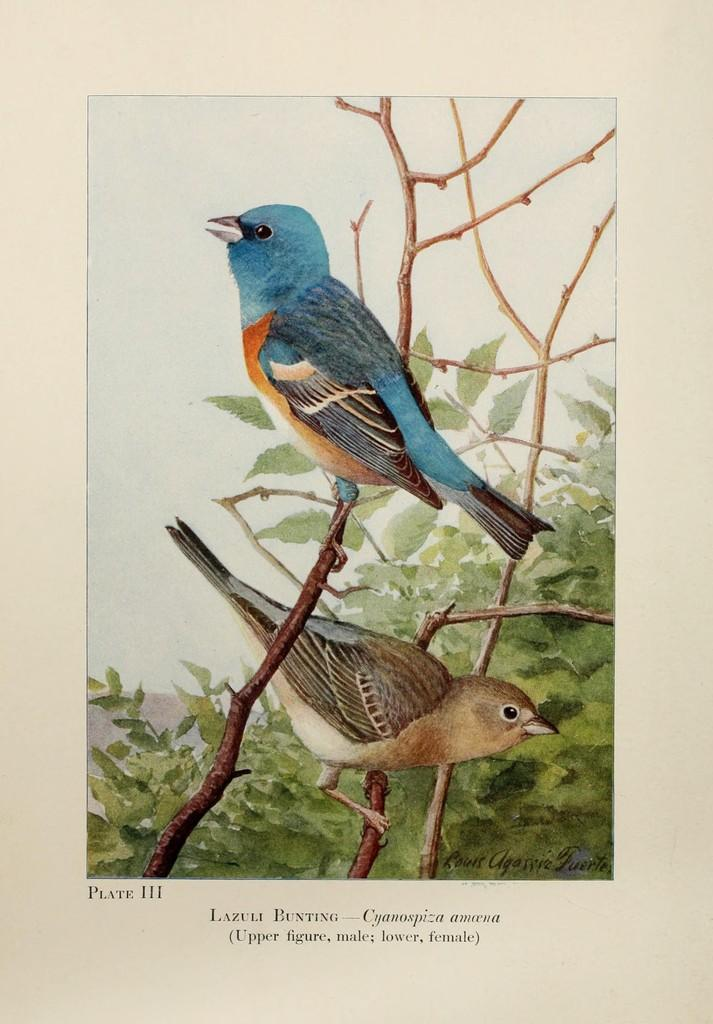How many birds can be seen in the image? There are two birds in the image. Where are the birds located in the image? The birds are on branches in the image. What else can be seen in the image besides the birds? Leaves are present in the image. What is written or depicted at the bottom of the image? There is text at the bottom of the image. What is the chance of a giraffe appearing in the image? There is no giraffe present in the image, so the chance of it appearing is zero. 